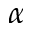Convert formula to latex. <formula><loc_0><loc_0><loc_500><loc_500>\alpha</formula> 